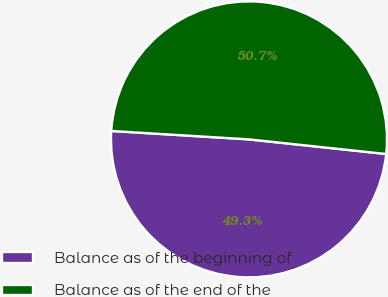Convert chart. <chart><loc_0><loc_0><loc_500><loc_500><pie_chart><fcel>Balance as of the beginning of<fcel>Balance as of the end of the<nl><fcel>49.28%<fcel>50.72%<nl></chart> 